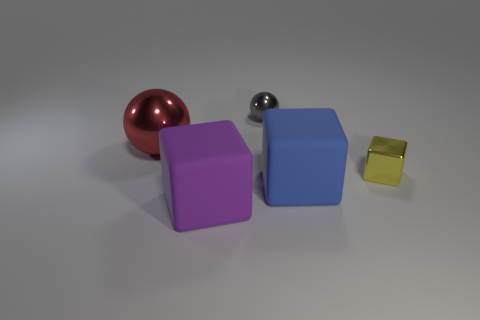There is a big thing on the right side of the cube that is to the left of the big block that is on the right side of the large purple cube; what shape is it?
Your answer should be very brief. Cube. Does the yellow cube have the same size as the matte cube on the right side of the purple cube?
Provide a short and direct response. No. Is there a brown metallic cylinder of the same size as the red metal object?
Offer a very short reply. No. What number of other things are made of the same material as the tiny gray ball?
Provide a short and direct response. 2. There is a thing that is both in front of the yellow cube and behind the purple cube; what color is it?
Offer a very short reply. Blue. Does the small thing that is behind the large red ball have the same material as the tiny object that is in front of the large ball?
Your response must be concise. Yes. Do the yellow object on the right side of the blue cube and the gray shiny object have the same size?
Make the answer very short. Yes. Does the big shiny ball have the same color as the big cube on the right side of the large purple block?
Give a very brief answer. No. The large red thing has what shape?
Provide a short and direct response. Sphere. Is the color of the tiny sphere the same as the large metal thing?
Your answer should be very brief. No. 